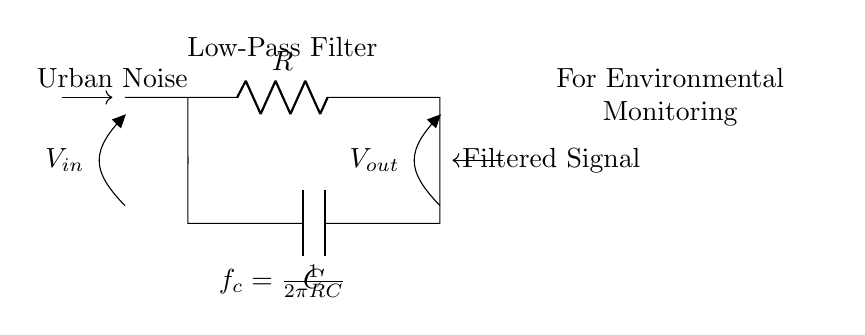What does the resistor represent in this circuit? The resistor in a low-pass filter circuit limits the current and helps set the cutoff frequency along with the capacitor.
Answer: Resistor What is the role of the capacitor in this filter circuit? The capacitor stores energy and allows AC signals to pass while blocking DC signals, working with the resistor to filter out high-frequency noise.
Answer: Capacitor What is the cutoff frequency formula indicated in the circuit? The formula displayed is for calculating the cutoff frequency, which is determined by the values of the resistor and capacitor in the circuit: f_c = 1/(2πRC).
Answer: f_c = 1/(2πRC) What type of filter is represented by this circuit? The circuit diagram depicts a low-pass filter, which allows signals with a frequency lower than the cutoff frequency to pass and attenuates higher frequencies.
Answer: Low-pass filter What type of signal is input into this circuit? The input signal specified in the diagram is urban noise, indicating that this filter is designed to reduce unwanted noise in environmental monitoring applications.
Answer: Urban Noise What happens to the signal after passing through the low-pass filter? After passing through the filter, the output is a filtered signal, which has the high-frequency noise removed, making it cleaner for analysis.
Answer: Filtered Signal 